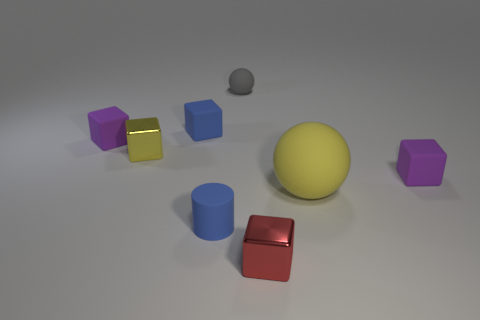Subtract all red cubes. How many cubes are left? 4 Subtract all small blue blocks. How many blocks are left? 4 Subtract all brown blocks. Subtract all green cylinders. How many blocks are left? 5 Add 2 small red spheres. How many objects exist? 10 Subtract all blocks. How many objects are left? 3 Subtract 0 cyan cylinders. How many objects are left? 8 Subtract all large yellow matte things. Subtract all small purple matte cubes. How many objects are left? 5 Add 4 tiny blue rubber cubes. How many tiny blue rubber cubes are left? 5 Add 6 purple rubber cubes. How many purple rubber cubes exist? 8 